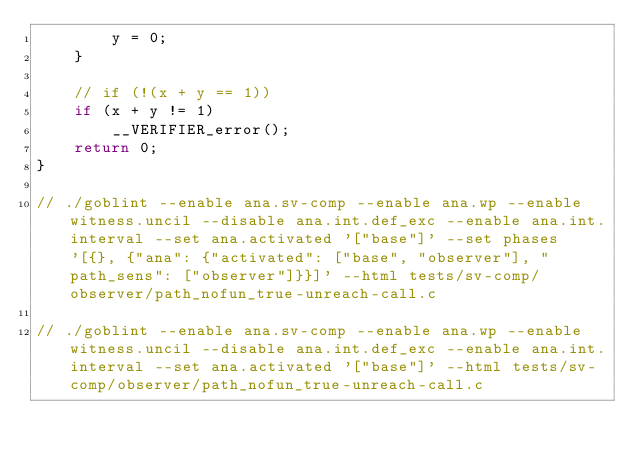<code> <loc_0><loc_0><loc_500><loc_500><_C_>        y = 0;
    }

    // if (!(x + y == 1))
    if (x + y != 1)
        __VERIFIER_error();
    return 0;
}

// ./goblint --enable ana.sv-comp --enable ana.wp --enable witness.uncil --disable ana.int.def_exc --enable ana.int.interval --set ana.activated '["base"]' --set phases '[{}, {"ana": {"activated": ["base", "observer"], "path_sens": ["observer"]}}]' --html tests/sv-comp/observer/path_nofun_true-unreach-call.c

// ./goblint --enable ana.sv-comp --enable ana.wp --enable witness.uncil --disable ana.int.def_exc --enable ana.int.interval --set ana.activated '["base"]' --html tests/sv-comp/observer/path_nofun_true-unreach-call.c
</code> 